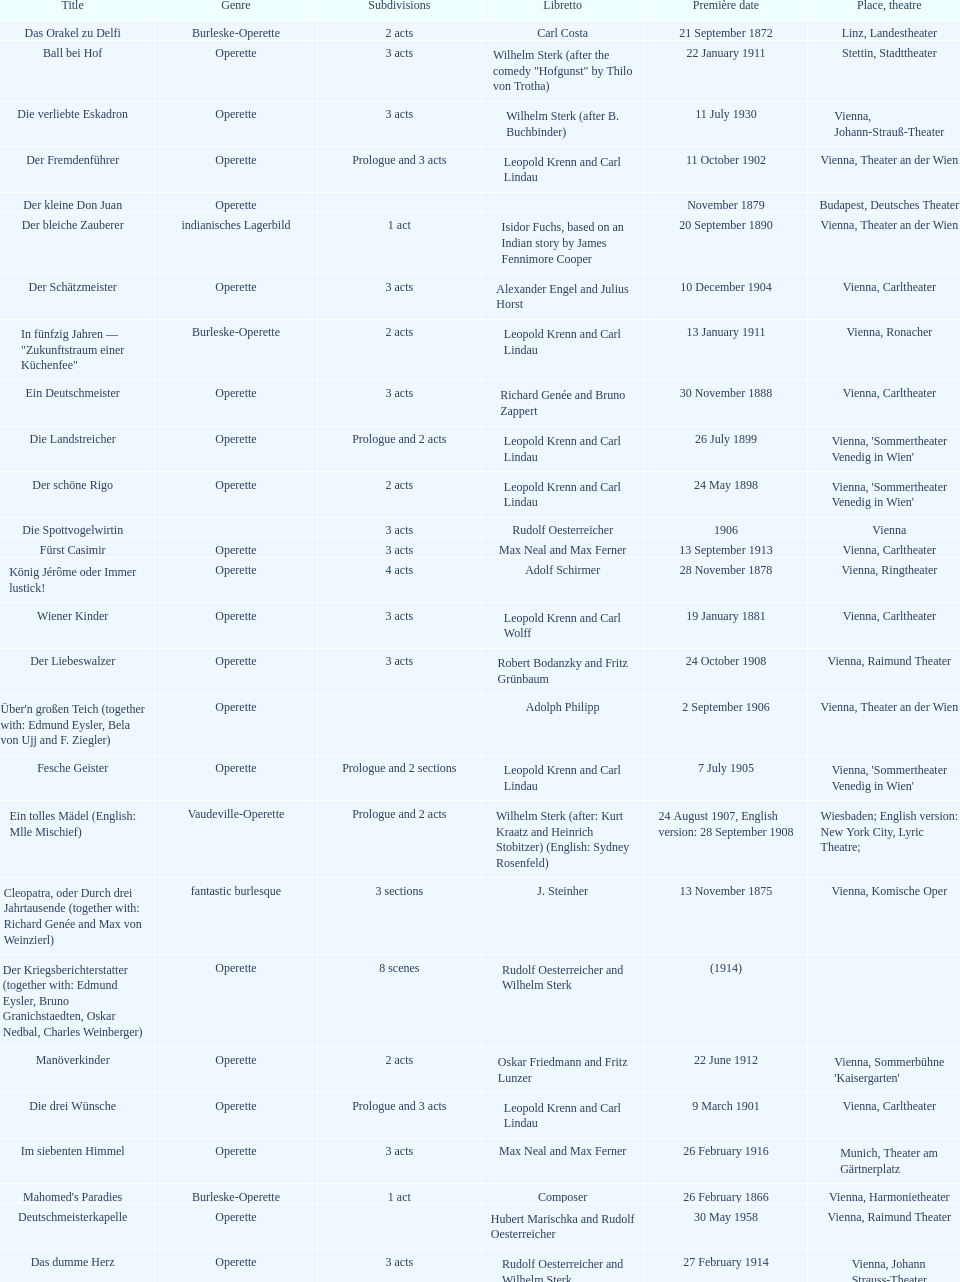Does der liebeswalzer or manöverkinder contain more acts? Der Liebeswalzer. 